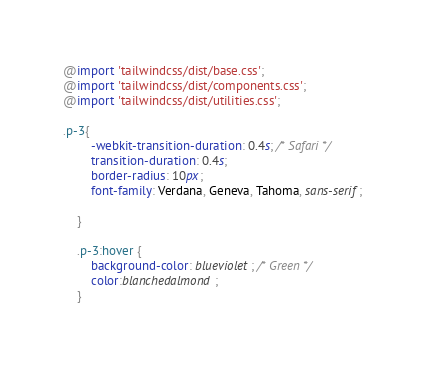Convert code to text. <code><loc_0><loc_0><loc_500><loc_500><_CSS_>@import 'tailwindcss/dist/base.css';
@import 'tailwindcss/dist/components.css';
@import 'tailwindcss/dist/utilities.css';

.p-3{
        -webkit-transition-duration: 0.4s; /* Safari */
        transition-duration: 0.4s;
        border-radius: 10px;
        font-family: Verdana, Geneva, Tahoma, sans-serif;

    }
    
    .p-3:hover {
        background-color: blueviolet; /* Green */
        color:blanchedalmond;
    }
</code> 